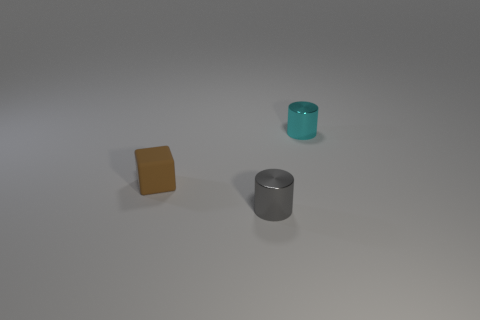The matte object has what color? The matte object, which appears to be a cube, has a shade that resembles mustard or a dark shade of yellow. 